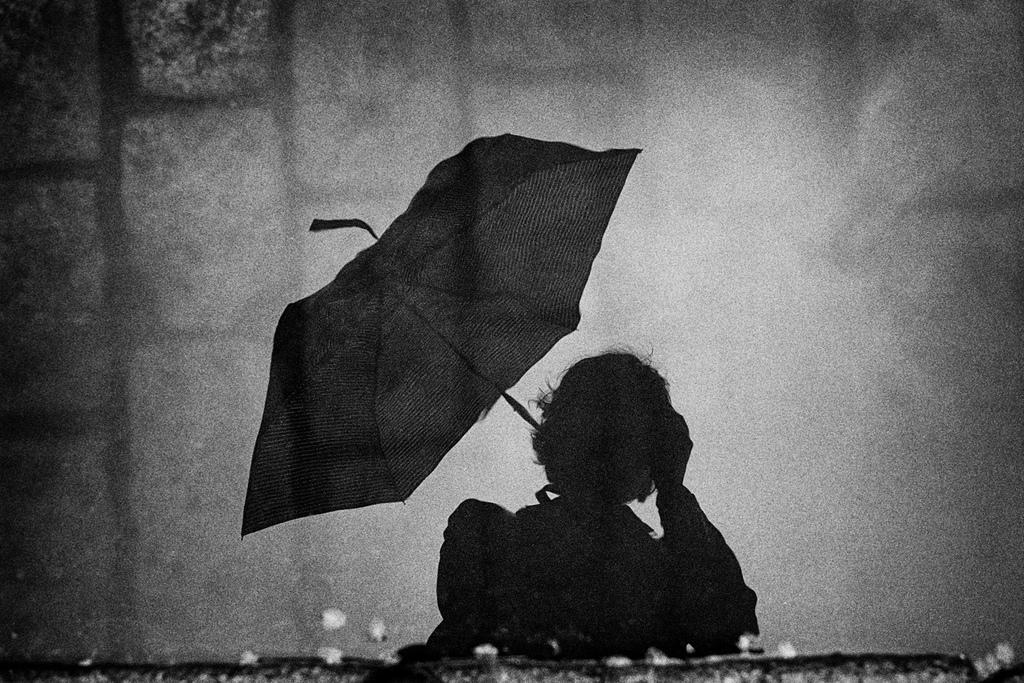What can be seen in the image through the shadows? There are shadows of a person and an umbrella in the image. Where are the shadows located? The shadows are on a wall. How many quarters can be seen in the image? There are no quarters visible in the image; it only features shadows of a person and an umbrella on a wall. 